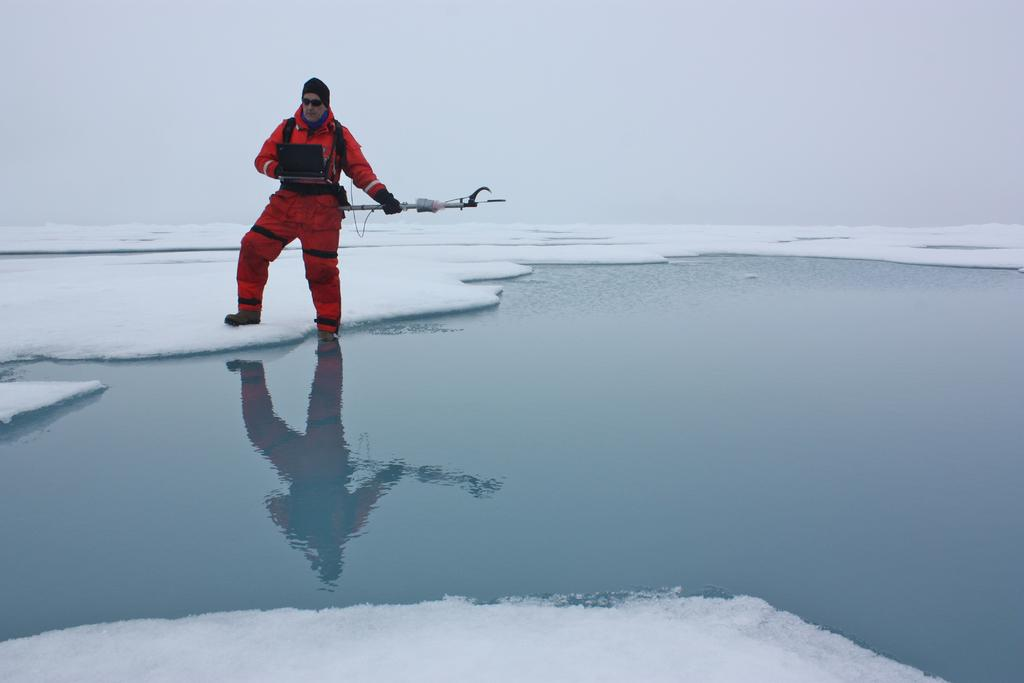What is the main subject of the image? There is a man standing in the image. What is the man holding in his hand? The man is holding a stick in his hand. What is the condition of the ground in the image? There is snow and water on the ground. What is visible at the top of the image? The sky is visible at the top of the image. What type of wine is the man drinking in the image? There is no wine present in the image; the man is holding a stick. Can you describe the argument between the man and the woman in the image? There is no woman or argument present in the image; it only features a man holding a stick. 